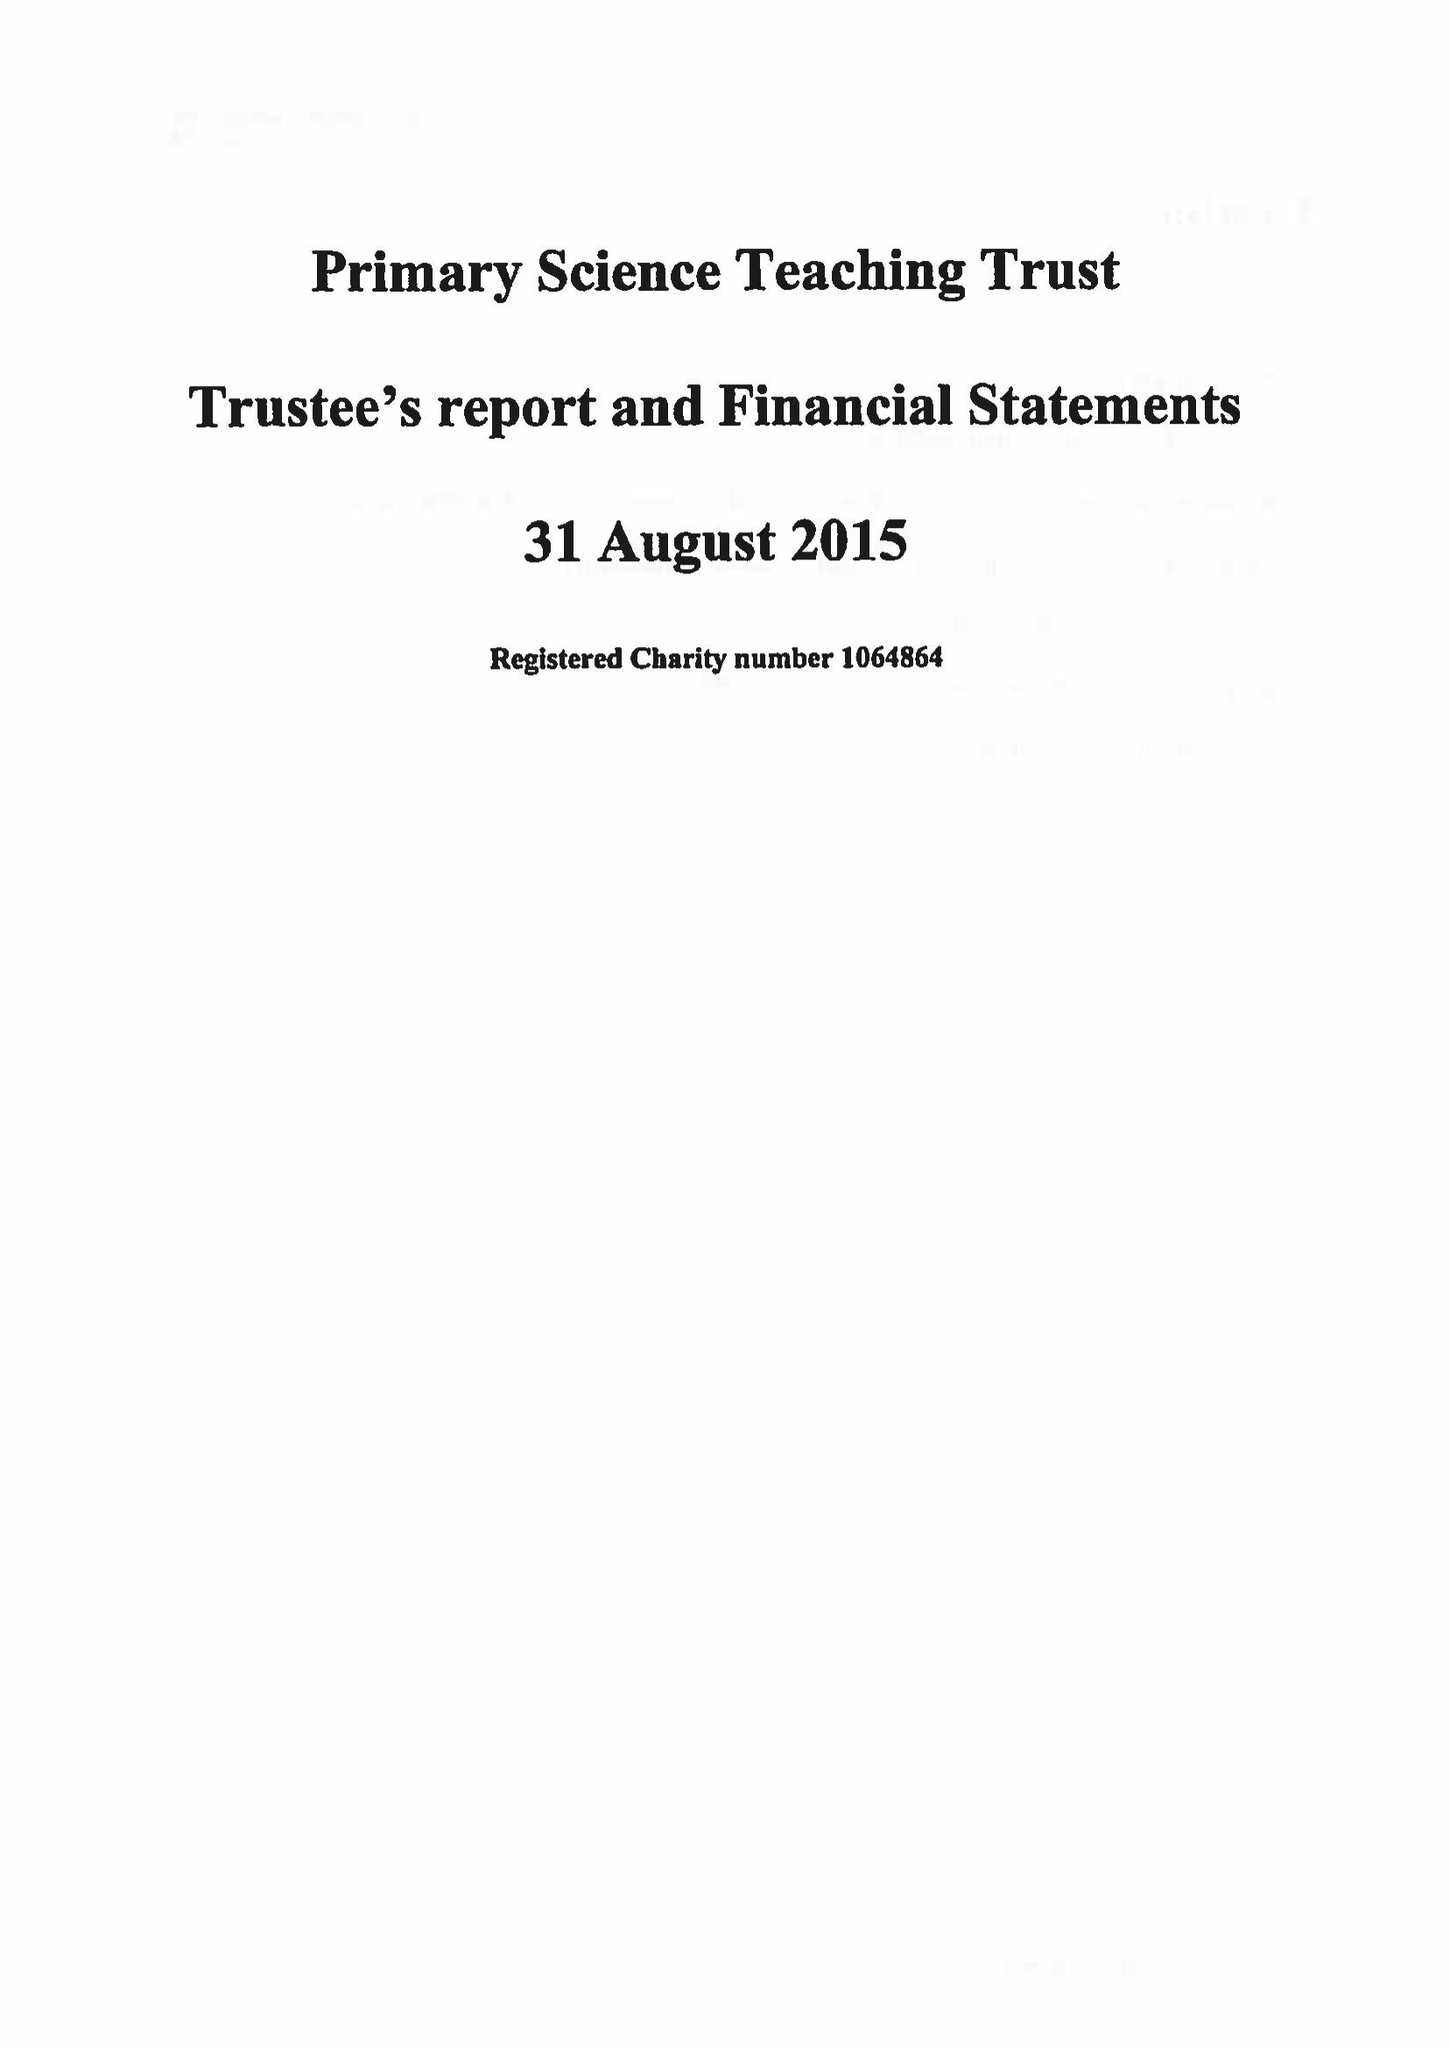What is the value for the charity_number?
Answer the question using a single word or phrase. 1064864 